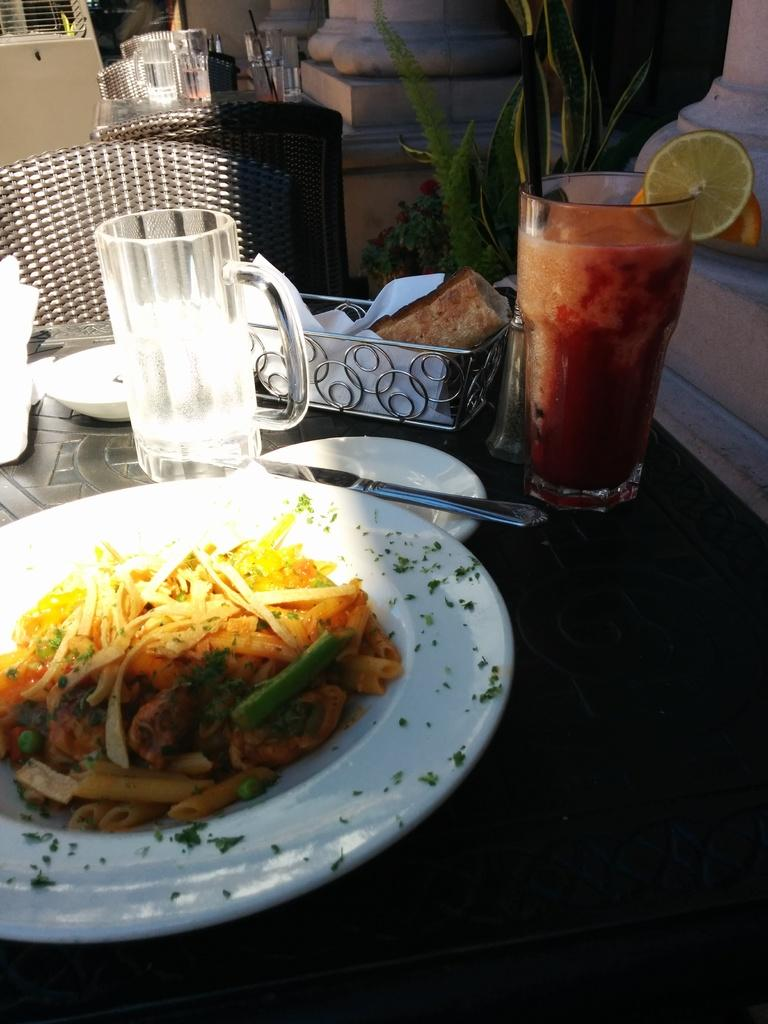What types of food items are present on the table in the image? There are eatables on the table in the image. What beverages can be seen on the table? There are drinks on the table in the image. Can you describe any other objects visible in the background of the image? Unfortunately, the provided facts do not give any information about objects in the background. What type of wool is being used to create the tail of the animal in the image? There is no animal or wool present in the image; it only shows eatables, drinks, and other objects on the table. 